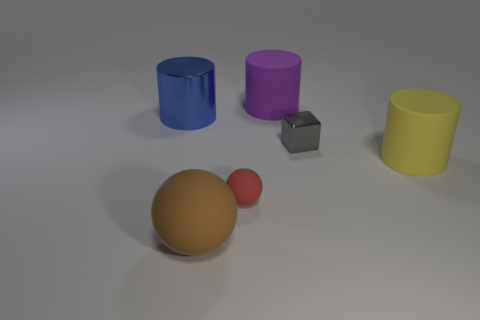Subtract all yellow cylinders. How many cylinders are left? 2 Add 1 gray cubes. How many objects exist? 7 Subtract all cubes. How many objects are left? 5 Subtract all gray cylinders. Subtract all purple cubes. How many cylinders are left? 3 Subtract 1 red spheres. How many objects are left? 5 Subtract all big purple matte spheres. Subtract all small rubber balls. How many objects are left? 5 Add 1 yellow matte things. How many yellow matte things are left? 2 Add 5 purple cylinders. How many purple cylinders exist? 6 